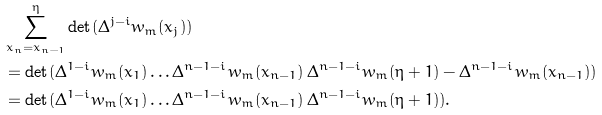Convert formula to latex. <formula><loc_0><loc_0><loc_500><loc_500>& \sum _ { x _ { n } = x _ { n - 1 } } ^ { \eta } \det ( \Delta ^ { j - i } w _ { m } ( x _ { j } ) ) \\ & = \det ( \Delta ^ { 1 - i } w _ { m } ( x _ { 1 } ) \dots \Delta ^ { n - 1 - i } w _ { m } ( x _ { n - 1 } ) \, \Delta ^ { n - 1 - i } w _ { m } ( \eta + 1 ) - \Delta ^ { n - 1 - i } w _ { m } ( x _ { n - 1 } ) ) \\ & = \det ( \Delta ^ { 1 - i } w _ { m } ( x _ { 1 } ) \dots \Delta ^ { n - 1 - i } w _ { m } ( x _ { n - 1 } ) \, \Delta ^ { n - 1 - i } w _ { m } ( \eta + 1 ) ) .</formula> 